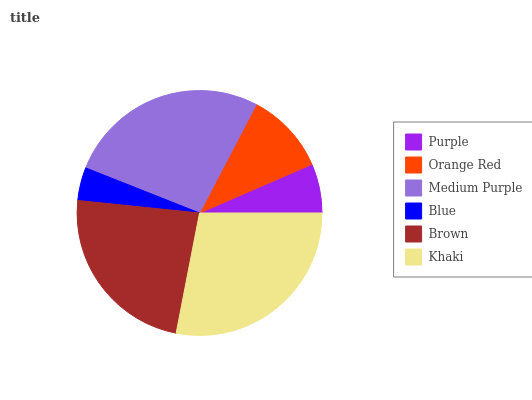Is Blue the minimum?
Answer yes or no. Yes. Is Khaki the maximum?
Answer yes or no. Yes. Is Orange Red the minimum?
Answer yes or no. No. Is Orange Red the maximum?
Answer yes or no. No. Is Orange Red greater than Purple?
Answer yes or no. Yes. Is Purple less than Orange Red?
Answer yes or no. Yes. Is Purple greater than Orange Red?
Answer yes or no. No. Is Orange Red less than Purple?
Answer yes or no. No. Is Brown the high median?
Answer yes or no. Yes. Is Orange Red the low median?
Answer yes or no. Yes. Is Blue the high median?
Answer yes or no. No. Is Medium Purple the low median?
Answer yes or no. No. 